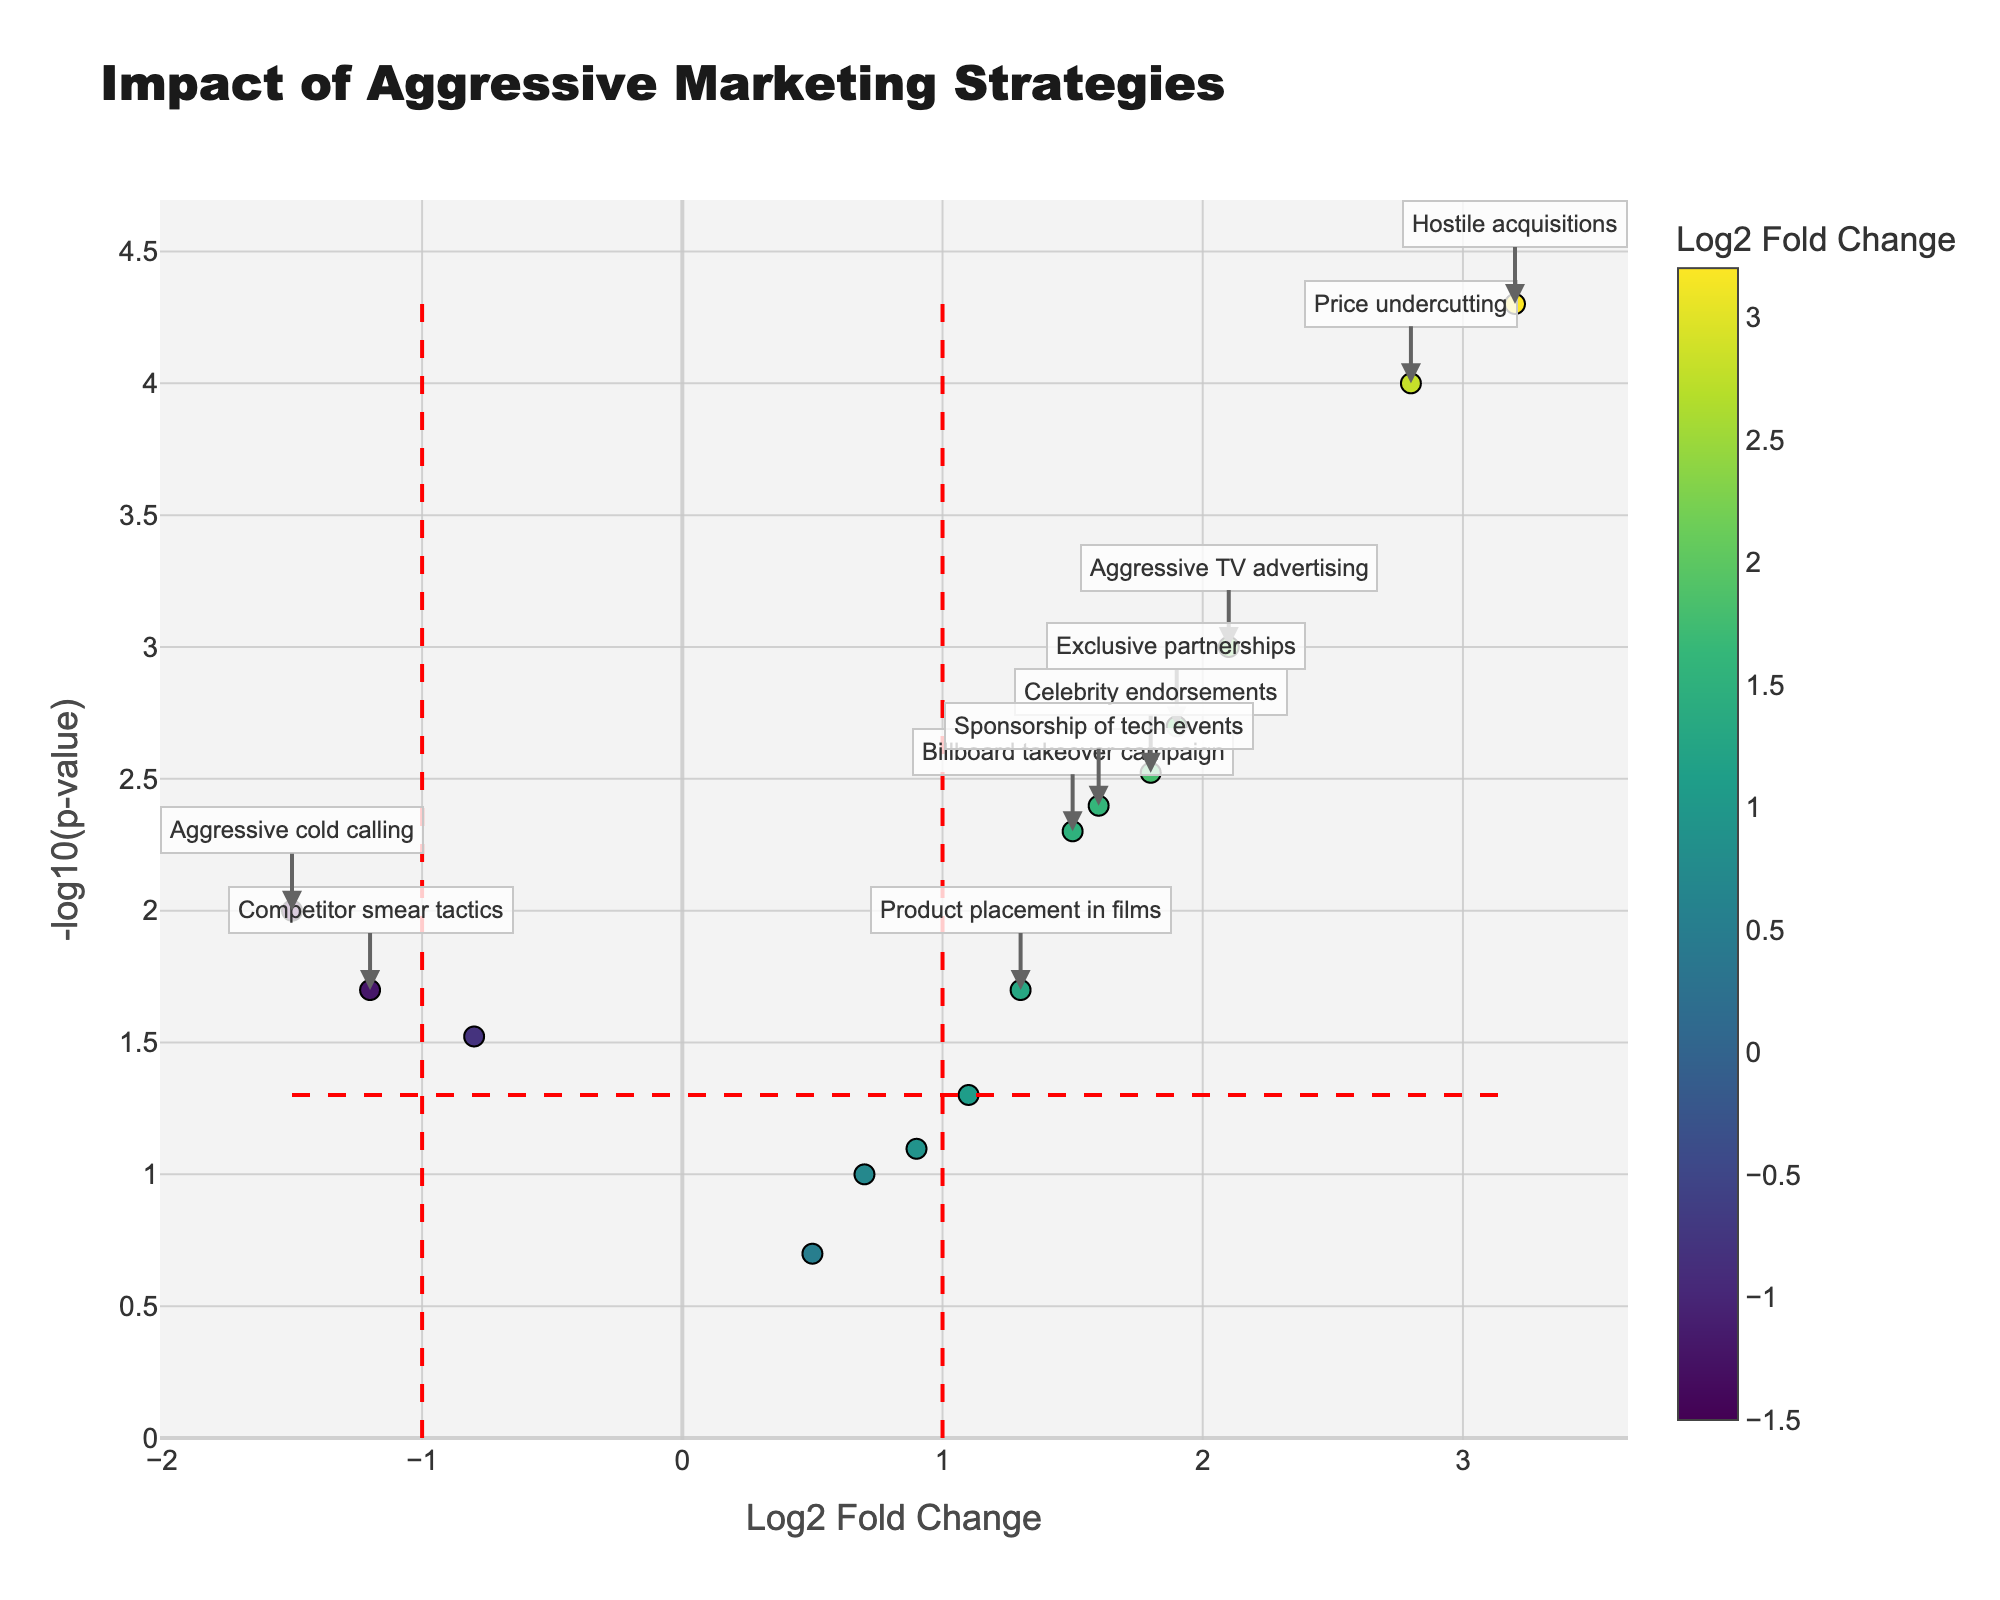What's the title of the plot? The title of the plot is visually displayed at the top and is intended to give a summary of the plot contents.
Answer: "Impact of Aggressive Marketing Strategies" What do the x-axis and y-axis represent? The x-axis is labeled "Log2 Fold Change" and the y-axis is labeled "-log10(p-value)." The x-axis shows how much the brand perception or market share changes on a logarithmic scale, while the y-axis shows the statistical significance of these changes.
Answer: Log2 Fold Change and -log10(p-value) How many marketing strategies have a Log2 Fold Change greater than 1? To determine this, count the number of data points to the right of the red dashed line at Log2 Fold Change = 1.
Answer: 9 Which marketing strategy has the highest level of statistical significance? The marketing strategy with the highest level of statistical significance will have the highest value on the y-axis (-log10(p-value)).
Answer: "Hostile acquisitions" Which strategies have a negative impact on brand perception or market share? The strategies with a negative Log2 Fold Change value and also significant will appear on the left side of the plot, below the red line on the x-axis and above the red line on the y-axis.
Answer: "Social media influencer blitz," "Competitor smear tactics," "Aggressive cold calling" What is the Log2 Fold Change for "Price undercutting"? To find this, locate the "Price undercutting" point on the plot and read its x-coordinate.
Answer: 2.8 Which strategy has both Log2 Fold Change greater than 2 and p-value less than 0.01? Strategies must be to the right of the red vertical line at Log2 Fold Change = 2 and above the red horizontal line at -log10(p-value) = 2 (which corresponds to p-value < 0.01).
Answer: "Hostile acquisitions," "Price undercutting" How many strategies have statistically significant p-values (p-value < 0.05)? Count the number of points above the red dashed horizontal line at -log10(p-value) = 1.3 (corresponding to p-value < 0.05).
Answer: 11 What's the relationship between "Billboard takeover campaign" and "Exclusive partnerships" in terms of Log2 Fold Change? Compare the x-coordinates of these two strategies.
Answer: "Exclusive partnerships" has a slightly higher Log2 Fold Change than "Billboard takeover campaign" Which strategies are notable for their high positive impact and high statistical significance? Identify the points in the top right quadrant, above -log10(p-value) = 1.3 and to the right of Log2 Fold Change = 1.
Answer: "Price undercutting," "Exclusive partnerships," "Celebrity endorsements," "Hostile acquisitions," "Aggressive TV advertising," "Billboard takeover campaign," "Sponsorship of tech events" 